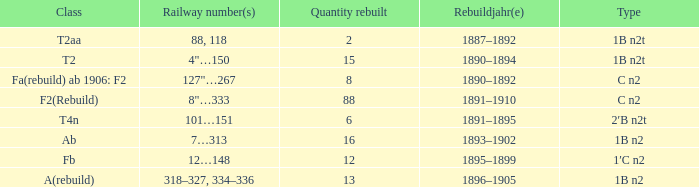If the type is 1b n2t and the railway numbers are 88 and 118, what is the total rebuilt quantity? 1.0. 